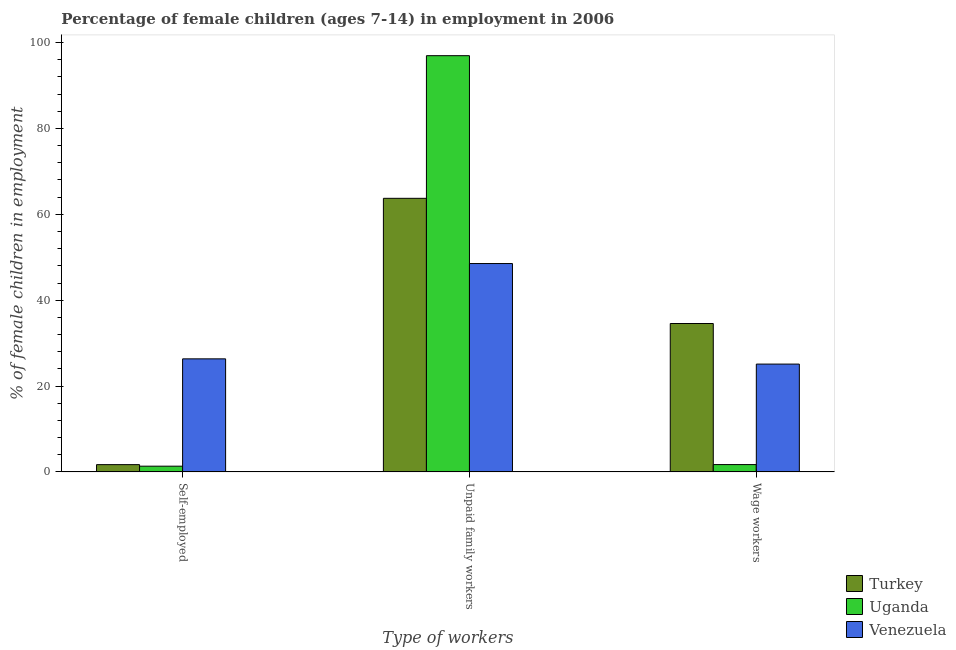How many groups of bars are there?
Your answer should be very brief. 3. Are the number of bars on each tick of the X-axis equal?
Your answer should be compact. Yes. How many bars are there on the 3rd tick from the left?
Ensure brevity in your answer.  3. What is the label of the 3rd group of bars from the left?
Your response must be concise. Wage workers. What is the percentage of children employed as unpaid family workers in Uganda?
Give a very brief answer. 96.95. Across all countries, what is the maximum percentage of self employed children?
Make the answer very short. 26.34. Across all countries, what is the minimum percentage of children employed as wage workers?
Provide a short and direct response. 1.71. In which country was the percentage of children employed as unpaid family workers maximum?
Give a very brief answer. Uganda. In which country was the percentage of children employed as wage workers minimum?
Make the answer very short. Uganda. What is the total percentage of children employed as wage workers in the graph?
Provide a short and direct response. 61.4. What is the difference between the percentage of self employed children in Turkey and that in Uganda?
Keep it short and to the point. 0.36. What is the difference between the percentage of children employed as wage workers in Turkey and the percentage of children employed as unpaid family workers in Venezuela?
Offer a terse response. -13.97. What is the average percentage of self employed children per country?
Your answer should be very brief. 9.79. What is the difference between the percentage of children employed as unpaid family workers and percentage of self employed children in Uganda?
Make the answer very short. 95.61. In how many countries, is the percentage of self employed children greater than 28 %?
Your answer should be compact. 0. What is the ratio of the percentage of self employed children in Turkey to that in Venezuela?
Your answer should be very brief. 0.06. Is the difference between the percentage of self employed children in Turkey and Uganda greater than the difference between the percentage of children employed as wage workers in Turkey and Uganda?
Give a very brief answer. No. What is the difference between the highest and the second highest percentage of self employed children?
Your answer should be compact. 24.64. What is the difference between the highest and the lowest percentage of children employed as wage workers?
Your response must be concise. 32.86. Is the sum of the percentage of children employed as wage workers in Uganda and Turkey greater than the maximum percentage of children employed as unpaid family workers across all countries?
Your answer should be compact. No. What does the 2nd bar from the left in Self-employed represents?
Give a very brief answer. Uganda. What does the 2nd bar from the right in Self-employed represents?
Offer a very short reply. Uganda. Is it the case that in every country, the sum of the percentage of self employed children and percentage of children employed as unpaid family workers is greater than the percentage of children employed as wage workers?
Your answer should be compact. Yes. How many bars are there?
Your answer should be very brief. 9. Does the graph contain grids?
Your response must be concise. No. Where does the legend appear in the graph?
Your answer should be compact. Bottom right. How many legend labels are there?
Make the answer very short. 3. What is the title of the graph?
Give a very brief answer. Percentage of female children (ages 7-14) in employment in 2006. Does "Cote d'Ivoire" appear as one of the legend labels in the graph?
Ensure brevity in your answer.  No. What is the label or title of the X-axis?
Your response must be concise. Type of workers. What is the label or title of the Y-axis?
Provide a short and direct response. % of female children in employment. What is the % of female children in employment of Turkey in Self-employed?
Offer a very short reply. 1.7. What is the % of female children in employment of Uganda in Self-employed?
Your answer should be compact. 1.34. What is the % of female children in employment in Venezuela in Self-employed?
Your response must be concise. 26.34. What is the % of female children in employment in Turkey in Unpaid family workers?
Keep it short and to the point. 63.73. What is the % of female children in employment in Uganda in Unpaid family workers?
Provide a succinct answer. 96.95. What is the % of female children in employment of Venezuela in Unpaid family workers?
Ensure brevity in your answer.  48.54. What is the % of female children in employment of Turkey in Wage workers?
Offer a terse response. 34.57. What is the % of female children in employment in Uganda in Wage workers?
Your response must be concise. 1.71. What is the % of female children in employment of Venezuela in Wage workers?
Your answer should be compact. 25.12. Across all Type of workers, what is the maximum % of female children in employment of Turkey?
Provide a short and direct response. 63.73. Across all Type of workers, what is the maximum % of female children in employment in Uganda?
Keep it short and to the point. 96.95. Across all Type of workers, what is the maximum % of female children in employment in Venezuela?
Offer a very short reply. 48.54. Across all Type of workers, what is the minimum % of female children in employment in Turkey?
Provide a short and direct response. 1.7. Across all Type of workers, what is the minimum % of female children in employment in Uganda?
Give a very brief answer. 1.34. Across all Type of workers, what is the minimum % of female children in employment in Venezuela?
Provide a succinct answer. 25.12. What is the total % of female children in employment in Uganda in the graph?
Provide a short and direct response. 100. What is the total % of female children in employment in Venezuela in the graph?
Your answer should be compact. 100. What is the difference between the % of female children in employment in Turkey in Self-employed and that in Unpaid family workers?
Offer a very short reply. -62.03. What is the difference between the % of female children in employment of Uganda in Self-employed and that in Unpaid family workers?
Offer a terse response. -95.61. What is the difference between the % of female children in employment of Venezuela in Self-employed and that in Unpaid family workers?
Offer a very short reply. -22.2. What is the difference between the % of female children in employment of Turkey in Self-employed and that in Wage workers?
Offer a very short reply. -32.87. What is the difference between the % of female children in employment of Uganda in Self-employed and that in Wage workers?
Offer a terse response. -0.37. What is the difference between the % of female children in employment of Venezuela in Self-employed and that in Wage workers?
Your answer should be compact. 1.22. What is the difference between the % of female children in employment of Turkey in Unpaid family workers and that in Wage workers?
Make the answer very short. 29.16. What is the difference between the % of female children in employment of Uganda in Unpaid family workers and that in Wage workers?
Your answer should be very brief. 95.24. What is the difference between the % of female children in employment in Venezuela in Unpaid family workers and that in Wage workers?
Make the answer very short. 23.42. What is the difference between the % of female children in employment in Turkey in Self-employed and the % of female children in employment in Uganda in Unpaid family workers?
Provide a succinct answer. -95.25. What is the difference between the % of female children in employment in Turkey in Self-employed and the % of female children in employment in Venezuela in Unpaid family workers?
Ensure brevity in your answer.  -46.84. What is the difference between the % of female children in employment in Uganda in Self-employed and the % of female children in employment in Venezuela in Unpaid family workers?
Your answer should be very brief. -47.2. What is the difference between the % of female children in employment in Turkey in Self-employed and the % of female children in employment in Uganda in Wage workers?
Your response must be concise. -0.01. What is the difference between the % of female children in employment of Turkey in Self-employed and the % of female children in employment of Venezuela in Wage workers?
Offer a very short reply. -23.42. What is the difference between the % of female children in employment in Uganda in Self-employed and the % of female children in employment in Venezuela in Wage workers?
Keep it short and to the point. -23.78. What is the difference between the % of female children in employment of Turkey in Unpaid family workers and the % of female children in employment of Uganda in Wage workers?
Give a very brief answer. 62.02. What is the difference between the % of female children in employment of Turkey in Unpaid family workers and the % of female children in employment of Venezuela in Wage workers?
Provide a succinct answer. 38.61. What is the difference between the % of female children in employment in Uganda in Unpaid family workers and the % of female children in employment in Venezuela in Wage workers?
Your answer should be very brief. 71.83. What is the average % of female children in employment in Turkey per Type of workers?
Your response must be concise. 33.33. What is the average % of female children in employment of Uganda per Type of workers?
Your answer should be compact. 33.33. What is the average % of female children in employment in Venezuela per Type of workers?
Your response must be concise. 33.33. What is the difference between the % of female children in employment in Turkey and % of female children in employment in Uganda in Self-employed?
Offer a terse response. 0.36. What is the difference between the % of female children in employment of Turkey and % of female children in employment of Venezuela in Self-employed?
Provide a short and direct response. -24.64. What is the difference between the % of female children in employment in Uganda and % of female children in employment in Venezuela in Self-employed?
Your response must be concise. -25. What is the difference between the % of female children in employment in Turkey and % of female children in employment in Uganda in Unpaid family workers?
Offer a very short reply. -33.22. What is the difference between the % of female children in employment in Turkey and % of female children in employment in Venezuela in Unpaid family workers?
Give a very brief answer. 15.19. What is the difference between the % of female children in employment of Uganda and % of female children in employment of Venezuela in Unpaid family workers?
Offer a very short reply. 48.41. What is the difference between the % of female children in employment of Turkey and % of female children in employment of Uganda in Wage workers?
Offer a very short reply. 32.86. What is the difference between the % of female children in employment of Turkey and % of female children in employment of Venezuela in Wage workers?
Provide a succinct answer. 9.45. What is the difference between the % of female children in employment of Uganda and % of female children in employment of Venezuela in Wage workers?
Offer a terse response. -23.41. What is the ratio of the % of female children in employment of Turkey in Self-employed to that in Unpaid family workers?
Your answer should be compact. 0.03. What is the ratio of the % of female children in employment in Uganda in Self-employed to that in Unpaid family workers?
Your answer should be compact. 0.01. What is the ratio of the % of female children in employment of Venezuela in Self-employed to that in Unpaid family workers?
Give a very brief answer. 0.54. What is the ratio of the % of female children in employment in Turkey in Self-employed to that in Wage workers?
Provide a succinct answer. 0.05. What is the ratio of the % of female children in employment in Uganda in Self-employed to that in Wage workers?
Make the answer very short. 0.78. What is the ratio of the % of female children in employment in Venezuela in Self-employed to that in Wage workers?
Your answer should be very brief. 1.05. What is the ratio of the % of female children in employment in Turkey in Unpaid family workers to that in Wage workers?
Your answer should be very brief. 1.84. What is the ratio of the % of female children in employment in Uganda in Unpaid family workers to that in Wage workers?
Ensure brevity in your answer.  56.7. What is the ratio of the % of female children in employment in Venezuela in Unpaid family workers to that in Wage workers?
Ensure brevity in your answer.  1.93. What is the difference between the highest and the second highest % of female children in employment in Turkey?
Offer a very short reply. 29.16. What is the difference between the highest and the second highest % of female children in employment of Uganda?
Your answer should be compact. 95.24. What is the difference between the highest and the lowest % of female children in employment in Turkey?
Your answer should be very brief. 62.03. What is the difference between the highest and the lowest % of female children in employment of Uganda?
Your answer should be compact. 95.61. What is the difference between the highest and the lowest % of female children in employment in Venezuela?
Give a very brief answer. 23.42. 